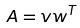<formula> <loc_0><loc_0><loc_500><loc_500>A = v w ^ { T }</formula> 